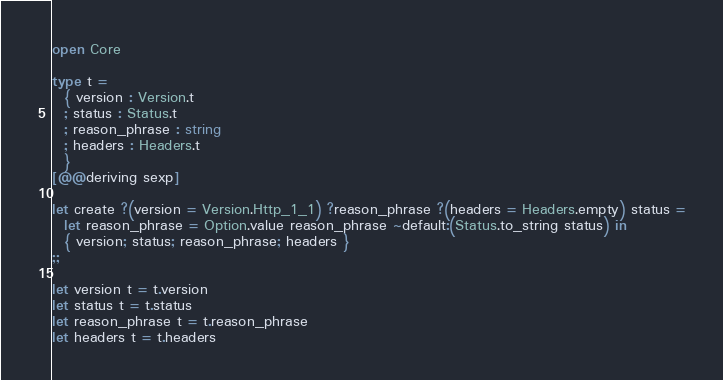<code> <loc_0><loc_0><loc_500><loc_500><_OCaml_>open Core

type t =
  { version : Version.t
  ; status : Status.t
  ; reason_phrase : string
  ; headers : Headers.t
  }
[@@deriving sexp]

let create ?(version = Version.Http_1_1) ?reason_phrase ?(headers = Headers.empty) status =
  let reason_phrase = Option.value reason_phrase ~default:(Status.to_string status) in
  { version; status; reason_phrase; headers }
;;

let version t = t.version
let status t = t.status
let reason_phrase t = t.reason_phrase
let headers t = t.headers
</code> 